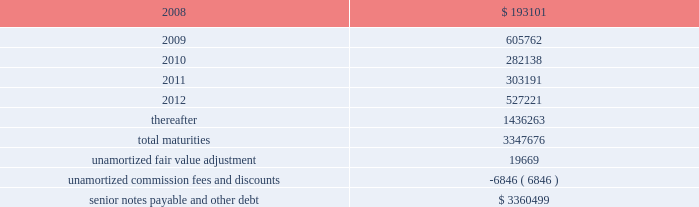Ventas , inc .
Notes to consolidated financial statements 2014 ( continued ) applicable indenture .
The issuers may also redeem the 2015 senior notes , in whole at any time or in part from time to time , on or after june 1 , 2010 at varying redemption prices set forth in the applicable indenture , plus accrued and unpaid interest thereon to the redemption date .
In addition , at any time prior to june 1 , 2008 , the issuers may redeem up to 35% ( 35 % ) of the aggregate principal amount of either or both of the 2010 senior notes and 2015 senior notes with the net cash proceeds from certain equity offerings at redemption prices equal to 106.750% ( 106.750 % ) and 107.125% ( 107.125 % ) , respectively , of the principal amount thereof , plus , in each case , accrued and unpaid interest thereon to the redemption date .
The issuers may redeem the 2014 senior notes , in whole at any time or in part from time to time , ( i ) prior to october 15 , 2009 at a redemption price equal to 100% ( 100 % ) of the principal amount thereof , plus a make-whole premium as described in the applicable indenture and ( ii ) on or after october 15 , 2009 at varying redemption prices set forth in the applicable indenture , plus , in each case , accrued and unpaid interest thereon to the redemption date .
The issuers may redeem the 2009 senior notes and the 2012 senior notes , in whole at any time or in part from time to time , at a redemption price equal to 100% ( 100 % ) of the principal amount thereof , plus accrued and unpaid interest thereon to the redemption date and a make-whole premium as described in the applicable indenture .
If we experience certain kinds of changes of control , the issuers must make an offer to repurchase the senior notes , in whole or in part , at a purchase price in cash equal to 101% ( 101 % ) of the principal amount of the senior notes , plus any accrued and unpaid interest to the date of purchase ; provided , however , that in the event moody 2019s and s&p have confirmed their ratings at ba3 or higher and bb- or higher on the senior notes and certain other conditions are met , this repurchase obligation will not apply .
Mortgages at december 31 , 2007 , we had outstanding 121 mortgage loans totaling $ 1.57 billion that are collateralized by the underlying assets of the properties .
Outstanding principal balances on these loans ranged from $ 0.4 million to $ 59.4 million as of december 31 , 2007 .
The loans generally bear interest at fixed rates ranging from 5.4% ( 5.4 % ) to 8.5% ( 8.5 % ) per annum , except for 15 loans with outstanding principal balances ranging from $ 0.4 million to $ 32.0 million , which bear interest at the lender 2019s variable rates ranging from 3.4% ( 3.4 % ) to 7.3% ( 7.3 % ) per annum as of december 31 , 2007 .
At december 31 , 2007 , the weighted average annual rate on fixed rate debt was 6.5% ( 6.5 % ) and the weighted average annual rate on the variable rate debt was 6.1% ( 6.1 % ) .
The loans had a weighted average maturity of 7.0 years as of december 31 , 2007 .
Sunrise 2019s portion of total debt was $ 157.1 million as of december 31 , scheduled maturities of borrowing arrangements and other provisions as of december 31 , 2007 , our indebtedness had the following maturities ( in thousands ) : .

What was the percent of the maturities as of 2008 as part of the total maturities? 
Rationale: the percent rate is the amount divided by the total amount
Computations: (193101 / 3347676)
Answer: 0.05768. 